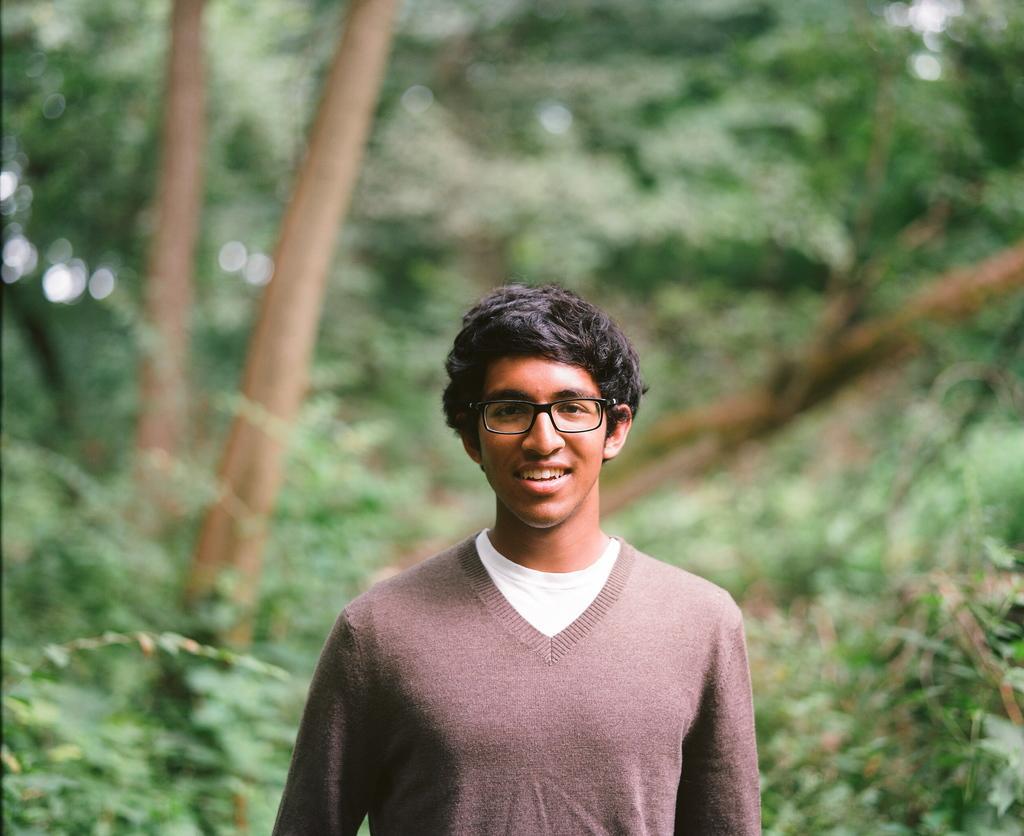Can you describe this image briefly? In this image there is a person posing for the camera with a smile on his face, behind the person there are trees. 